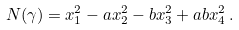Convert formula to latex. <formula><loc_0><loc_0><loc_500><loc_500>N ( \gamma ) = x _ { 1 } ^ { 2 } - a x _ { 2 } ^ { 2 } - b x _ { 3 } ^ { 2 } + a b x _ { 4 } ^ { 2 } \, .</formula> 